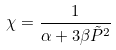<formula> <loc_0><loc_0><loc_500><loc_500>\chi = \frac { 1 } { \alpha + 3 \beta \tilde { P } ^ { 2 } }</formula> 